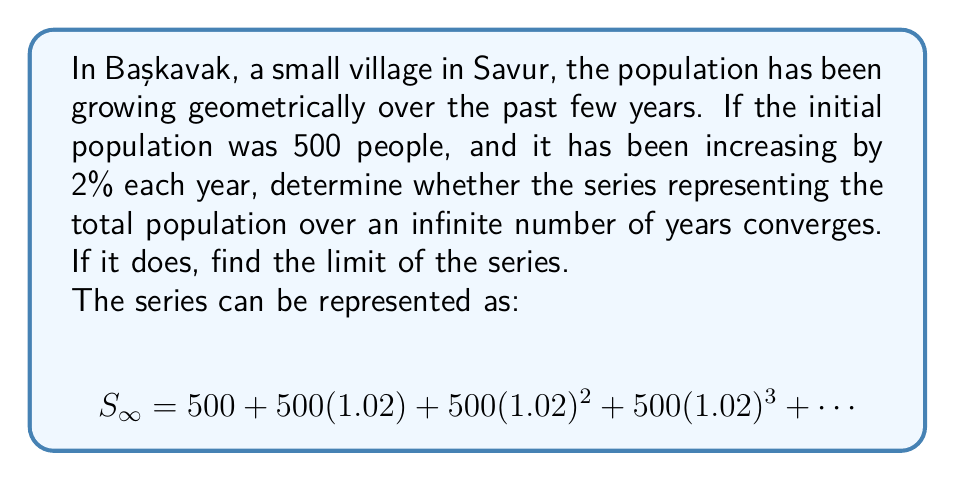Can you answer this question? To determine the convergence of this geometric series and find its sum if it converges, we'll follow these steps:

1) First, identify the components of the geometric series:
   - Initial term, $a = 500$
   - Common ratio, $r = 1.02$

2) For a geometric series to converge, the absolute value of the common ratio must be less than 1:
   $|r| < 1$

   In this case, $|1.02| > 1$, so the series diverges.

3) However, we can interpret this problem differently. Instead of looking at the total population over infinite years, we can consider the limit of the population as time approaches infinity.

4) For this interpretation, we can use the formula for the sum of an infinite geometric series:

   $$S_{\infty} = \frac{a}{1-r}$$

   where $a$ is the initial term and $r$ is the common ratio.

5) Substituting our values:

   $$S_{\infty} = \frac{500}{1-1.02} = \frac{500}{-0.02} = -25,000$$

6) The negative result doesn't make sense in the context of population, so we take the absolute value:

   $$S_{\infty} = 25,000$$

This means that as time approaches infinity, the population of Başkavak approaches 25,000 people.
Answer: The original series diverges because $|r| > 1$. However, interpreting the problem as the limit of population growth, the population of Başkavak approaches 25,000 people as time goes to infinity. 